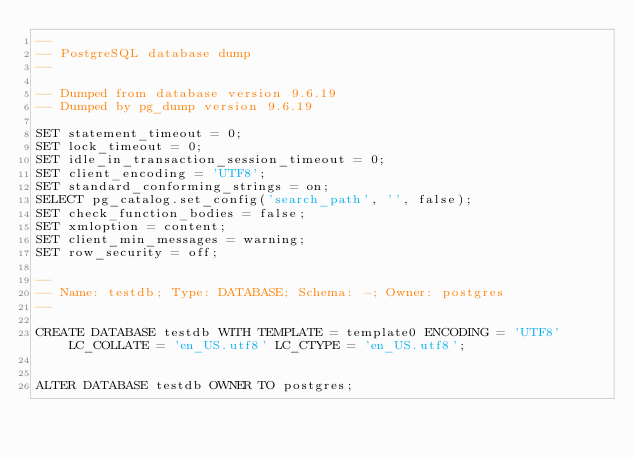<code> <loc_0><loc_0><loc_500><loc_500><_SQL_>--
-- PostgreSQL database dump
--

-- Dumped from database version 9.6.19
-- Dumped by pg_dump version 9.6.19

SET statement_timeout = 0;
SET lock_timeout = 0;
SET idle_in_transaction_session_timeout = 0;
SET client_encoding = 'UTF8';
SET standard_conforming_strings = on;
SELECT pg_catalog.set_config('search_path', '', false);
SET check_function_bodies = false;
SET xmloption = content;
SET client_min_messages = warning;
SET row_security = off;

--
-- Name: testdb; Type: DATABASE; Schema: -; Owner: postgres
--

CREATE DATABASE testdb WITH TEMPLATE = template0 ENCODING = 'UTF8' LC_COLLATE = 'en_US.utf8' LC_CTYPE = 'en_US.utf8';


ALTER DATABASE testdb OWNER TO postgres;
</code> 